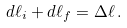<formula> <loc_0><loc_0><loc_500><loc_500>d \ell _ { i } + d \ell _ { f } = \Delta \ell \, .</formula> 